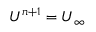<formula> <loc_0><loc_0><loc_500><loc_500>U ^ { n + 1 } = U _ { \infty }</formula> 